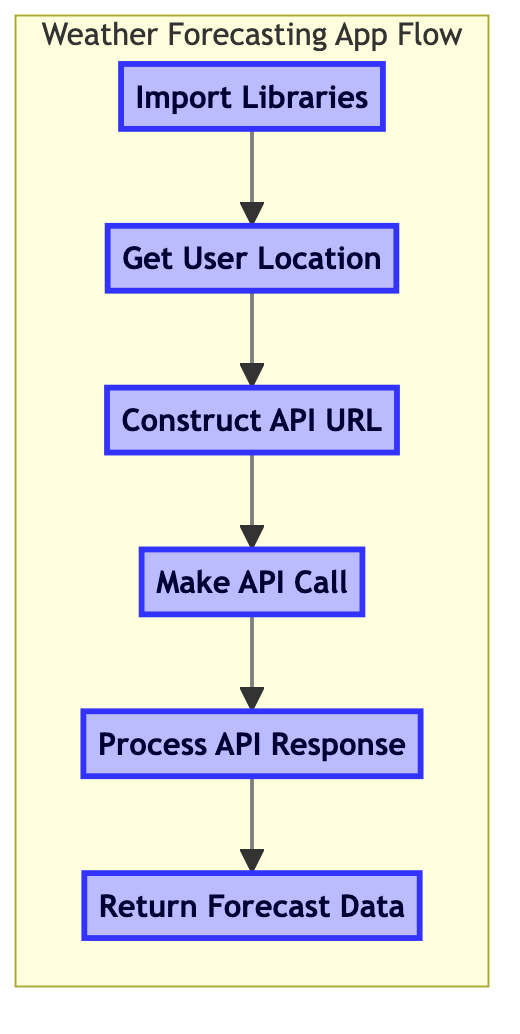What is the first step in the flow of the diagram? The diagram begins with the "Import Libraries" step, which is the first node in the flowchart. There are no other steps before this one.
Answer: Import Libraries How many steps are shown in the diagram? The diagram consists of six steps that flow from "Import Libraries" down to "Return Forecast Data." Counting each step gives a total of six.
Answer: Six What step comes immediately after "Get User Location"? "Construct API URL" directly follows "Get User Location" in the flowchart, indicating that it is the next action that occurs after obtaining the location.
Answer: Construct API URL What is the last step in the flowchart? The last step in the flowchart is "Return Forecast Data," which signifies the conclusion of the weather forecasting app process.
Answer: Return Forecast Data Which step involves user input? The "Get User Location" step involves user input, as it is where the application obtains the user's location, either through manual input or automated means.
Answer: Get User Location What is the relationship between "Make API Call" and "Process API Response"? "Make API Call" directly leads to "Process API Response," as the latter is the step that occurs immediately after the API call is made to interpret the response received.
Answer: Directly leads to If the API call fails, which step would be affected? If the API call fails, it would affect the "Process API Response" step, since there would be no valid data to process from the API response following a failed call.
Answer: Process API Response In which step do we handle JSON responses? The "Process API Response" step is where we handle JSON responses from the API, extracting and formatting the relevant weather data at this stage.
Answer: Process API Response What does the flowchart aim to achieve at the end? The flowchart aims to achieve the goal of returning processed weather forecast data at the end of the sequence, summarizing the result of all prior steps.
Answer: Return Forecast Data 